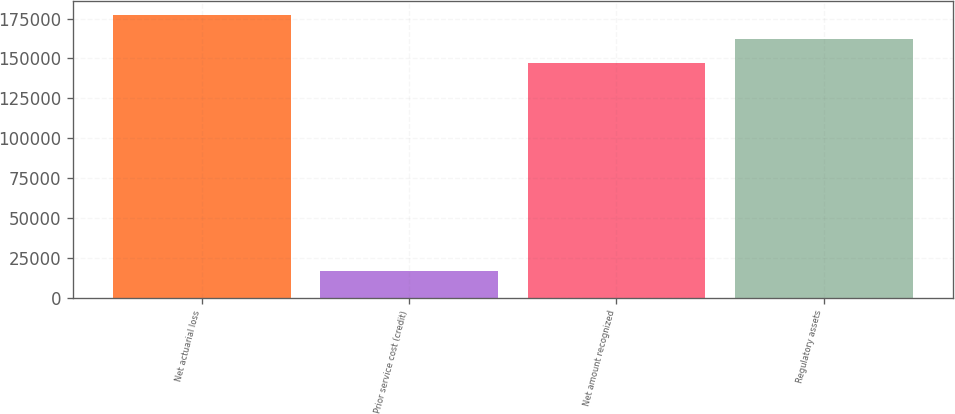Convert chart to OTSL. <chart><loc_0><loc_0><loc_500><loc_500><bar_chart><fcel>Net actuarial loss<fcel>Prior service cost (credit)<fcel>Net amount recognized<fcel>Regulatory assets<nl><fcel>176929<fcel>16864<fcel>147441<fcel>162185<nl></chart> 